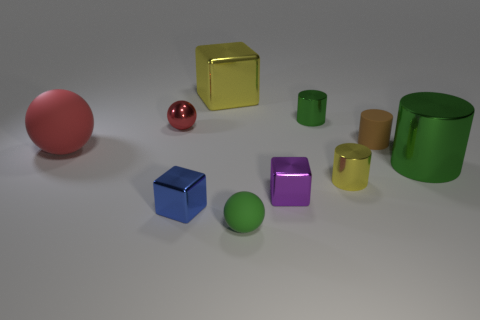What number of objects are on the left side of the small rubber thing that is in front of the small shiny cube to the left of the small green ball?
Make the answer very short. 4. What is the tiny green object that is behind the large metallic thing to the right of the tiny rubber thing that is in front of the blue cube made of?
Offer a terse response. Metal. Is the material of the large thing behind the brown cylinder the same as the large cylinder?
Provide a short and direct response. Yes. What number of red matte objects have the same size as the purple shiny block?
Provide a succinct answer. 0. Is the number of large cylinders to the left of the big matte thing greater than the number of small brown things behind the big yellow thing?
Your response must be concise. No. Are there any small blue metallic things of the same shape as the purple object?
Make the answer very short. Yes. What size is the ball to the right of the large shiny object that is behind the tiny metallic sphere?
Give a very brief answer. Small. What shape is the rubber object that is in front of the green object right of the tiny metallic cylinder in front of the small brown matte object?
Make the answer very short. Sphere. What size is the purple cube that is the same material as the tiny yellow object?
Offer a terse response. Small. Are there more tiny gray cylinders than small green matte things?
Keep it short and to the point. No. 